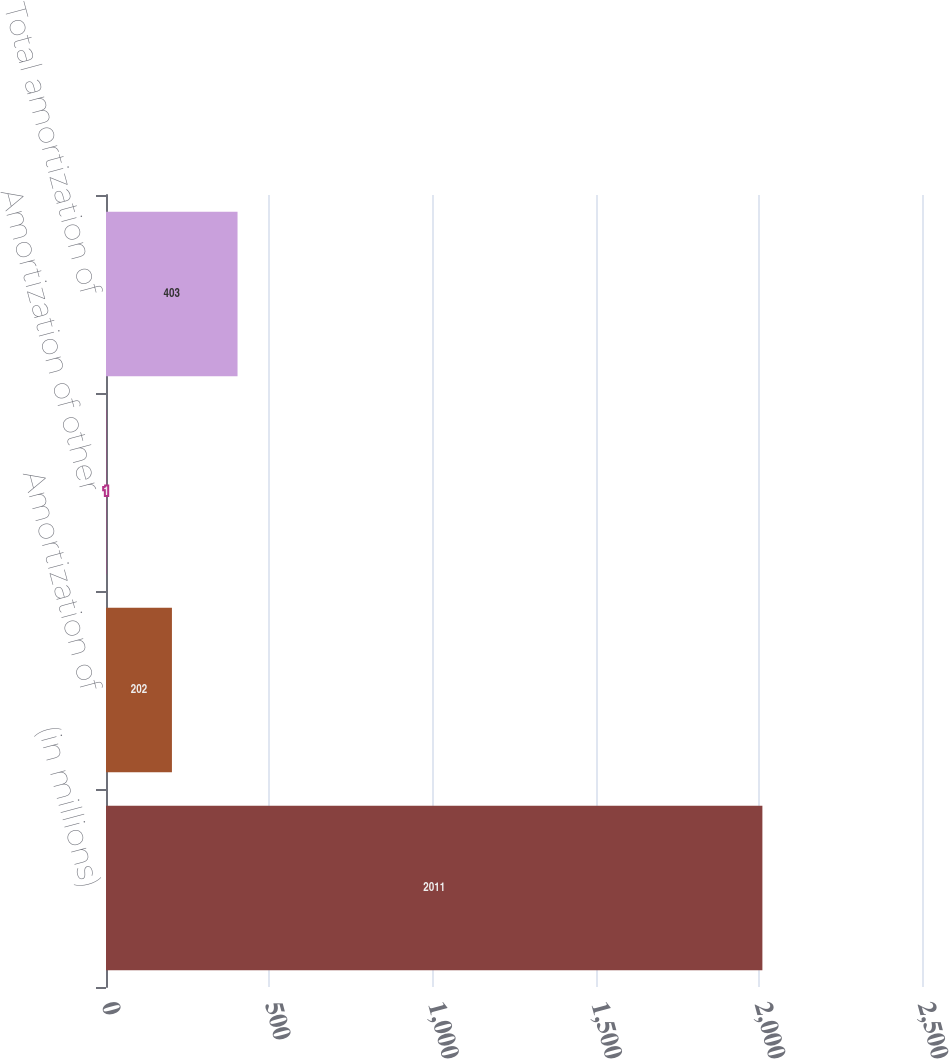Convert chart to OTSL. <chart><loc_0><loc_0><loc_500><loc_500><bar_chart><fcel>(in millions)<fcel>Amortization of<fcel>Amortization of other<fcel>Total amortization of<nl><fcel>2011<fcel>202<fcel>1<fcel>403<nl></chart> 